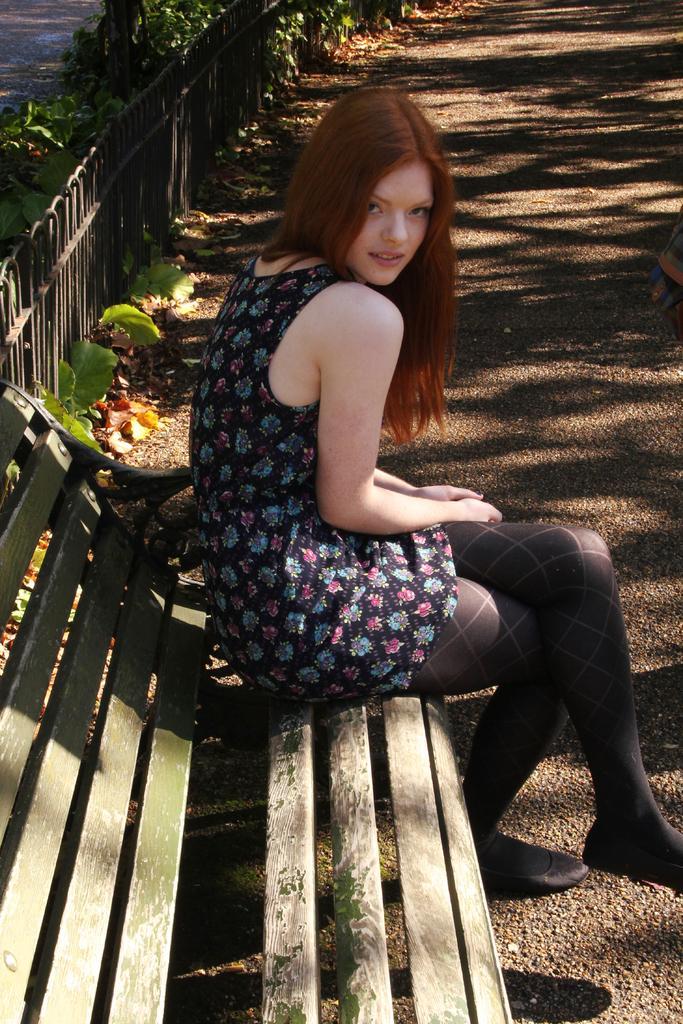Could you give a brief overview of what you see in this image? In this picture we can see a girl sitting on the wooden bench, smiling and giving a pose to the camera. Behind there is a black fencing railing and some green plants. 